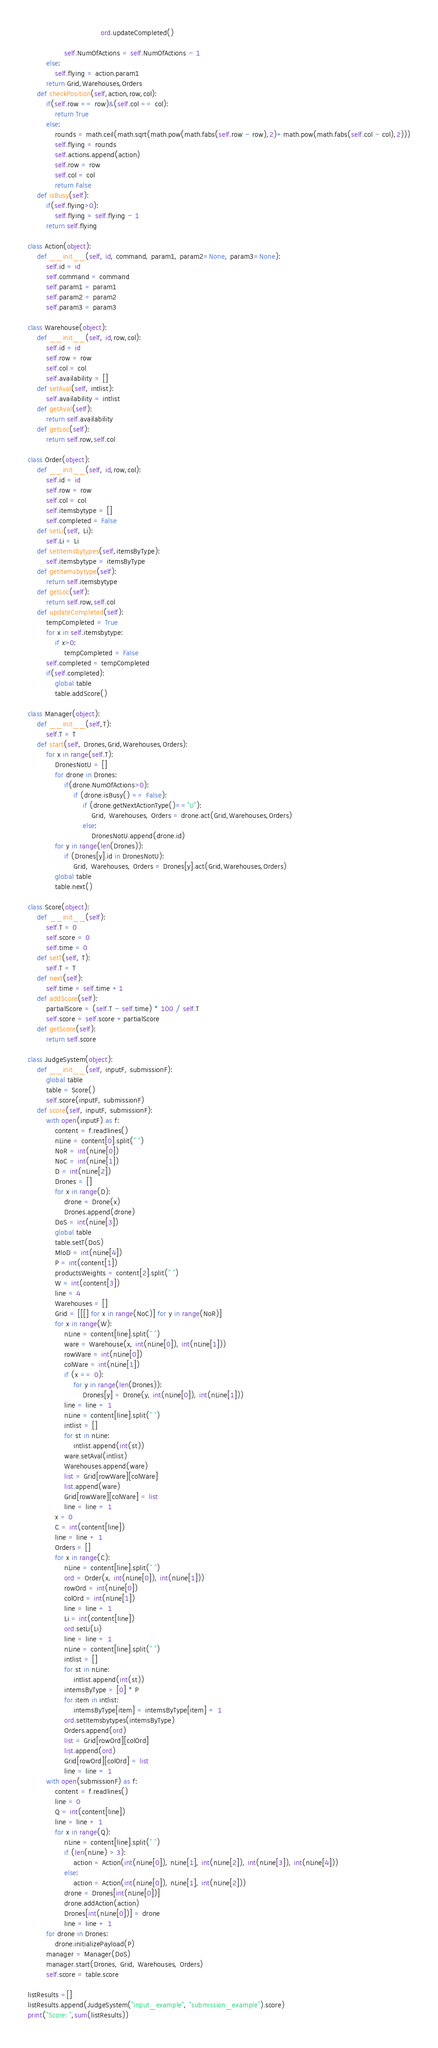<code> <loc_0><loc_0><loc_500><loc_500><_Python_>                                ord.updateCompleted()

                self.NumOfActions = self.NumOfActions - 1
        else:
            self.flying = action.param1
        return Grid,Warehouses,Orders
    def checkPosition(self,action,row,col):
        if(self.row == row)&(self.col == col):
            return True
        else:
            rounds = math.ceil(math.sqrt(math.pow(math.fabs(self.row - row),2)+math.pow(math.fabs(self.col - col),2)))
            self.flying = rounds
            self.actions.append(action)
            self.row = row
            self.col = col
            return False
    def isBusy(self):
        if(self.flying>0):
            self.flying = self.flying - 1
        return self.flying

class Action(object):
    def __init__(self, id, command, param1, param2=None, param3=None):
        self.id = id
        self.command = command
        self.param1 = param1
        self.param2 = param2
        self.param3 = param3

class Warehouse(object):
    def __init__(self, id,row,col):
        self.id = id
        self.row = row
        self.col = col
        self.availability = []
    def setAval(self, intlist):
        self.availability = intlist
    def getAval(self):
        return self.availability
    def getLoc(self):
        return self.row,self.col

class Order(object):
    def __init__(self, id,row,col):
        self.id = id
        self.row = row
        self.col = col
        self.itemsbytype = []
        self.completed = False
    def setLi(self, Li):
        self.Li = Li
    def setItemsbytypes(self,itemsByType):
        self.itemsbytype = itemsByType
    def getItemsbytype(self):
        return self.itemsbytype
    def getLoc(self):
        return self.row,self.col
    def updateCompleted(self):
        tempCompleted = True
        for x in self.itemsbytype:
            if x>0:
                tempCompleted = False
        self.completed = tempCompleted
        if(self.completed):
            global table
            table.addScore()

class Manager(object):
    def __init__(self,T):
        self.T = T
    def start(self, Drones,Grid,Warehouses,Orders):
        for x in range(self.T):
            DronesNotU = []
            for drone in Drones:
                if(drone.NumOfActions>0):
                    if (drone.isBusy() == False):
                        if (drone.getNextActionType()=="U"):
                            Grid, Warehouses, Orders = drone.act(Grid,Warehouses,Orders)
                        else:
                            DronesNotU.append(drone.id)
            for y in range(len(Drones)):
                if (Drones[y].id in DronesNotU):
                    Grid, Warehouses, Orders = Drones[y].act(Grid,Warehouses,Orders)
            global table
            table.next()

class Score(object):
    def __init__(self):
        self.T = 0
        self.score = 0
        self.time = 0
    def setT(self, T):
        self.T = T
    def next(self):
        self.time = self.time +1
    def addScore(self):
        partialScore = (self.T - self.time) * 100 / self.T
        self.score = self.score +partialScore
    def getScore(self):
        return self.score

class JudgeSystem(object):
    def __init__(self, inputF, submissionF):
        global table
        table = Score()
        self.score(inputF, submissionF)
    def score(self, inputF, submissionF):
        with open(inputF) as f:
            content = f.readlines()
            nLine = content[0].split(" ")
            NoR = int(nLine[0])
            NoC = int(nLine[1])
            D = int(nLine[2])
            Drones = []
            for x in range(D):
                drone = Drone(x)
                Drones.append(drone)
            DoS = int(nLine[3])
            global table
            table.setT(DoS)
            MloD = int(nLine[4])
            P = int(content[1])
            productsWeights = content[2].split(" ")
            W = int(content[3])
            line = 4
            Warehouses = []
            Grid = [[[] for x in range(NoC)] for y in range(NoR)]
            for x in range(W):
                nLine = content[line].split(" ")
                ware = Warehouse(x, int(nLine[0]), int(nLine[1]))
                rowWare = int(nLine[0])
                colWare = int(nLine[1])
                if (x == 0):
                    for y in range(len(Drones)):
                        Drones[y] = Drone(y, int(nLine[0]), int(nLine[1]))
                line = line + 1
                nLine = content[line].split(" ")
                intlist = []
                for st in nLine:
                    intlist.append(int(st))
                ware.setAval(intlist)
                Warehouses.append(ware)
                list = Grid[rowWare][colWare]
                list.append(ware)
                Grid[rowWare][colWare] = list
                line = line + 1
            x = 0
            C = int(content[line])
            line = line + 1
            Orders = []
            for x in range(C):
                nLine = content[line].split(" ")
                ord = Order(x, int(nLine[0]), int(nLine[1]))
                rowOrd = int(nLine[0])
                colOrd = int(nLine[1])
                line = line + 1
                Li = int(content[line])
                ord.setLi(Li)
                line = line + 1
                nLine = content[line].split(" ")
                intlist = []
                for st in nLine:
                    intlist.append(int(st))
                intemsByType = [0] * P
                for item in intlist:
                    intemsByType[item] = intemsByType[item] + 1
                ord.setItemsbytypes(intemsByType)
                Orders.append(ord)
                list = Grid[rowOrd][colOrd]
                list.append(ord)
                Grid[rowOrd][colOrd] = list
                line = line + 1
        with open(submissionF) as f:
            content = f.readlines()
            line = 0
            Q = int(content[line])
            line = line + 1
            for x in range(Q):
                nLine = content[line].split(" ")
                if (len(nLine) > 3):
                    action = Action(int(nLine[0]), nLine[1], int(nLine[2]), int(nLine[3]), int(nLine[4]))
                else:
                    action = Action(int(nLine[0]), nLine[1], int(nLine[2]))
                drone = Drones[int(nLine[0])]
                drone.addAction(action)
                Drones[int(nLine[0])] = drone
                line = line + 1
        for drone in Drones:
            drone.initializePayload(P)
        manager = Manager(DoS)
        manager.start(Drones, Grid, Warehouses, Orders)
        self.score = table.score

listResults =[]
listResults.append(JudgeSystem("input_example", "submission_example").score)
print("Score: ",sum(listResults))




</code> 